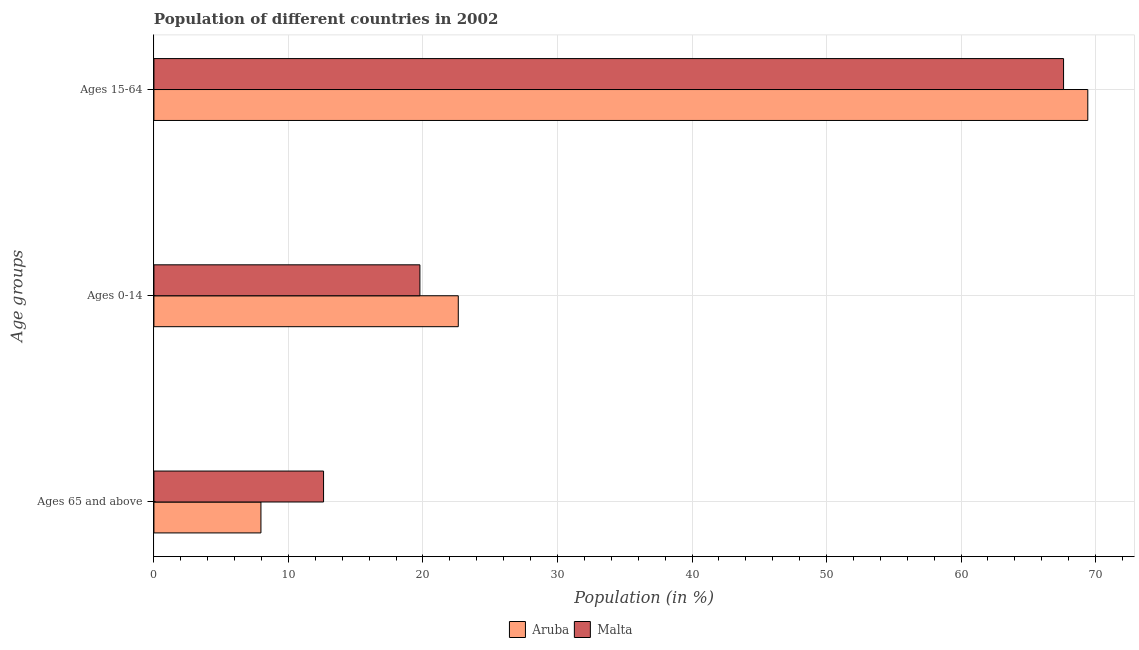How many groups of bars are there?
Your response must be concise. 3. Are the number of bars per tick equal to the number of legend labels?
Keep it short and to the point. Yes. How many bars are there on the 2nd tick from the top?
Give a very brief answer. 2. What is the label of the 1st group of bars from the top?
Ensure brevity in your answer.  Ages 15-64. What is the percentage of population within the age-group of 65 and above in Malta?
Give a very brief answer. 12.61. Across all countries, what is the maximum percentage of population within the age-group of 65 and above?
Keep it short and to the point. 12.61. Across all countries, what is the minimum percentage of population within the age-group 0-14?
Your answer should be compact. 19.77. In which country was the percentage of population within the age-group of 65 and above maximum?
Your answer should be compact. Malta. In which country was the percentage of population within the age-group 0-14 minimum?
Offer a very short reply. Malta. What is the total percentage of population within the age-group of 65 and above in the graph?
Ensure brevity in your answer.  20.57. What is the difference between the percentage of population within the age-group 15-64 in Aruba and that in Malta?
Give a very brief answer. 1.8. What is the difference between the percentage of population within the age-group 15-64 in Malta and the percentage of population within the age-group 0-14 in Aruba?
Your answer should be very brief. 44.99. What is the average percentage of population within the age-group of 65 and above per country?
Provide a short and direct response. 10.28. What is the difference between the percentage of population within the age-group 0-14 and percentage of population within the age-group of 65 and above in Malta?
Keep it short and to the point. 7.16. In how many countries, is the percentage of population within the age-group 15-64 greater than 68 %?
Provide a short and direct response. 1. What is the ratio of the percentage of population within the age-group 0-14 in Malta to that in Aruba?
Make the answer very short. 0.87. What is the difference between the highest and the second highest percentage of population within the age-group 0-14?
Your response must be concise. 2.85. What is the difference between the highest and the lowest percentage of population within the age-group 0-14?
Make the answer very short. 2.85. In how many countries, is the percentage of population within the age-group 0-14 greater than the average percentage of population within the age-group 0-14 taken over all countries?
Ensure brevity in your answer.  1. Is the sum of the percentage of population within the age-group of 65 and above in Aruba and Malta greater than the maximum percentage of population within the age-group 0-14 across all countries?
Provide a succinct answer. No. What does the 1st bar from the top in Ages 0-14 represents?
Provide a short and direct response. Malta. What does the 1st bar from the bottom in Ages 15-64 represents?
Make the answer very short. Aruba. Is it the case that in every country, the sum of the percentage of population within the age-group of 65 and above and percentage of population within the age-group 0-14 is greater than the percentage of population within the age-group 15-64?
Ensure brevity in your answer.  No. What is the difference between two consecutive major ticks on the X-axis?
Keep it short and to the point. 10. Does the graph contain any zero values?
Your answer should be compact. No. How are the legend labels stacked?
Keep it short and to the point. Horizontal. What is the title of the graph?
Offer a terse response. Population of different countries in 2002. Does "Guam" appear as one of the legend labels in the graph?
Offer a terse response. No. What is the label or title of the X-axis?
Provide a short and direct response. Population (in %). What is the label or title of the Y-axis?
Offer a very short reply. Age groups. What is the Population (in %) in Aruba in Ages 65 and above?
Give a very brief answer. 7.96. What is the Population (in %) of Malta in Ages 65 and above?
Give a very brief answer. 12.61. What is the Population (in %) in Aruba in Ages 0-14?
Provide a short and direct response. 22.62. What is the Population (in %) of Malta in Ages 0-14?
Your answer should be compact. 19.77. What is the Population (in %) in Aruba in Ages 15-64?
Offer a very short reply. 69.42. What is the Population (in %) of Malta in Ages 15-64?
Provide a short and direct response. 67.62. Across all Age groups, what is the maximum Population (in %) of Aruba?
Offer a terse response. 69.42. Across all Age groups, what is the maximum Population (in %) of Malta?
Offer a terse response. 67.62. Across all Age groups, what is the minimum Population (in %) of Aruba?
Offer a terse response. 7.96. Across all Age groups, what is the minimum Population (in %) in Malta?
Provide a succinct answer. 12.61. What is the difference between the Population (in %) in Aruba in Ages 65 and above and that in Ages 0-14?
Make the answer very short. -14.67. What is the difference between the Population (in %) in Malta in Ages 65 and above and that in Ages 0-14?
Provide a short and direct response. -7.16. What is the difference between the Population (in %) in Aruba in Ages 65 and above and that in Ages 15-64?
Give a very brief answer. -61.47. What is the difference between the Population (in %) of Malta in Ages 65 and above and that in Ages 15-64?
Your answer should be very brief. -55.01. What is the difference between the Population (in %) of Aruba in Ages 0-14 and that in Ages 15-64?
Your answer should be compact. -46.8. What is the difference between the Population (in %) of Malta in Ages 0-14 and that in Ages 15-64?
Your answer should be compact. -47.85. What is the difference between the Population (in %) of Aruba in Ages 65 and above and the Population (in %) of Malta in Ages 0-14?
Ensure brevity in your answer.  -11.82. What is the difference between the Population (in %) of Aruba in Ages 65 and above and the Population (in %) of Malta in Ages 15-64?
Keep it short and to the point. -59.66. What is the difference between the Population (in %) in Aruba in Ages 0-14 and the Population (in %) in Malta in Ages 15-64?
Provide a succinct answer. -44.99. What is the average Population (in %) of Aruba per Age groups?
Offer a very short reply. 33.33. What is the average Population (in %) of Malta per Age groups?
Give a very brief answer. 33.33. What is the difference between the Population (in %) of Aruba and Population (in %) of Malta in Ages 65 and above?
Offer a very short reply. -4.65. What is the difference between the Population (in %) in Aruba and Population (in %) in Malta in Ages 0-14?
Your answer should be very brief. 2.85. What is the difference between the Population (in %) of Aruba and Population (in %) of Malta in Ages 15-64?
Your answer should be very brief. 1.8. What is the ratio of the Population (in %) in Aruba in Ages 65 and above to that in Ages 0-14?
Offer a terse response. 0.35. What is the ratio of the Population (in %) of Malta in Ages 65 and above to that in Ages 0-14?
Offer a terse response. 0.64. What is the ratio of the Population (in %) of Aruba in Ages 65 and above to that in Ages 15-64?
Ensure brevity in your answer.  0.11. What is the ratio of the Population (in %) of Malta in Ages 65 and above to that in Ages 15-64?
Your answer should be very brief. 0.19. What is the ratio of the Population (in %) of Aruba in Ages 0-14 to that in Ages 15-64?
Give a very brief answer. 0.33. What is the ratio of the Population (in %) of Malta in Ages 0-14 to that in Ages 15-64?
Ensure brevity in your answer.  0.29. What is the difference between the highest and the second highest Population (in %) in Aruba?
Ensure brevity in your answer.  46.8. What is the difference between the highest and the second highest Population (in %) of Malta?
Give a very brief answer. 47.85. What is the difference between the highest and the lowest Population (in %) of Aruba?
Give a very brief answer. 61.47. What is the difference between the highest and the lowest Population (in %) of Malta?
Keep it short and to the point. 55.01. 